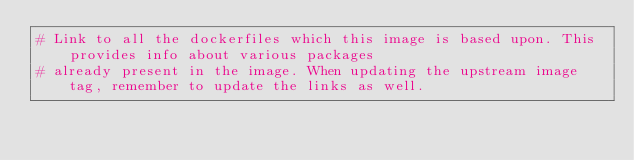<code> <loc_0><loc_0><loc_500><loc_500><_Dockerfile_># Link to all the dockerfiles which this image is based upon. This provides info about various packages
# already present in the image. When updating the upstream image tag, remember to update the links as well.
</code> 